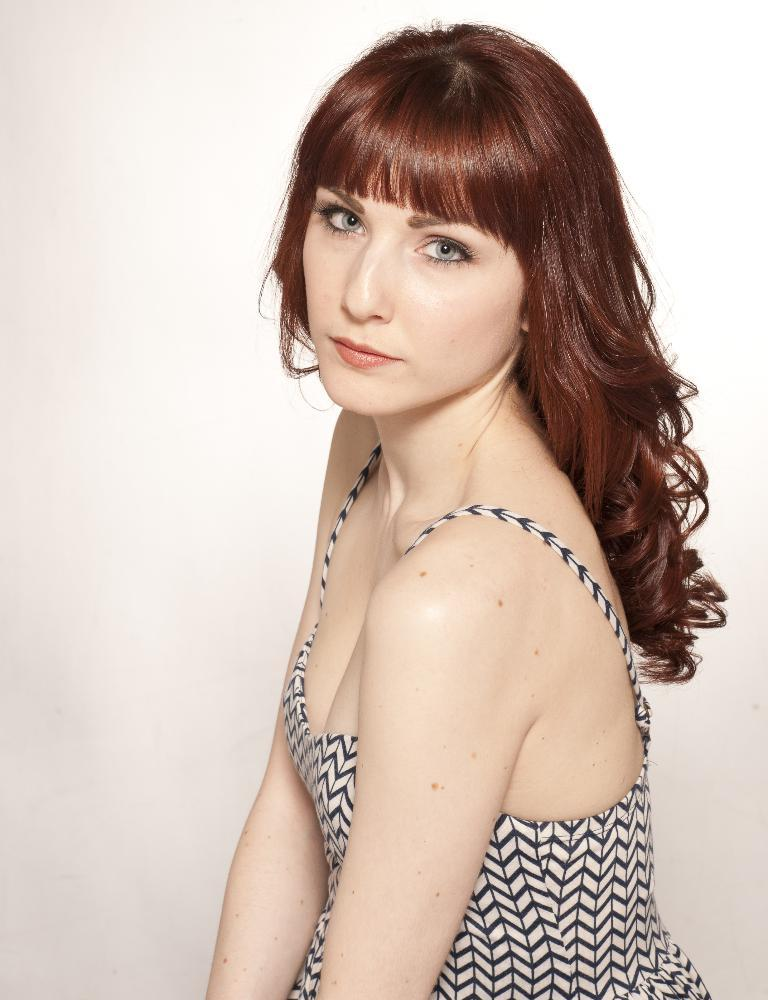What is the main subject of the image? The main subject of the image is a woman. Can you describe the woman's hair in the image? The woman has long hair in the image. What type of clothing is the woman wearing in the image? The woman is wearing a dress in the image. How many deer can be seen in the image? There are no deer present in the image. What color is the balloon that the woman is holding in the image? There is no balloon present in the image. 